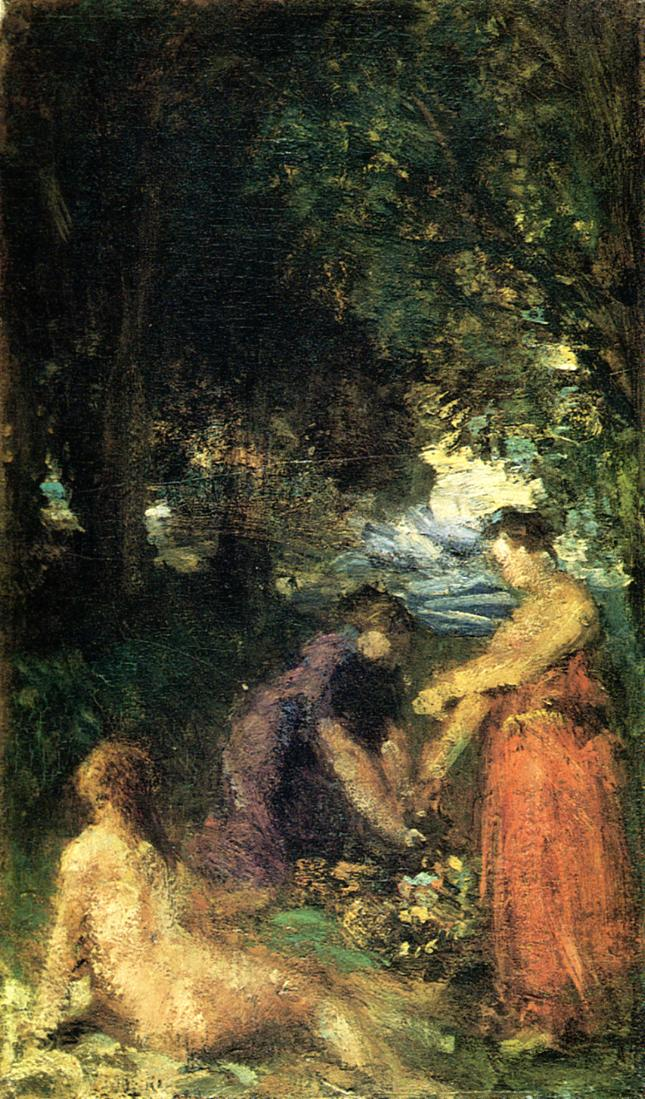What emotions might the figures in the painting be feeling? The figures in the painting likely feel a sense of tranquility, contentment, and perhaps a touch of camaraderie. Their relaxed postures and the way they seem absorbed in their surroundings suggest they are enjoying a peaceful moment away from the hustle and bustle of daily life. There might also be a sense of contemplation as they connect with nature around them. 